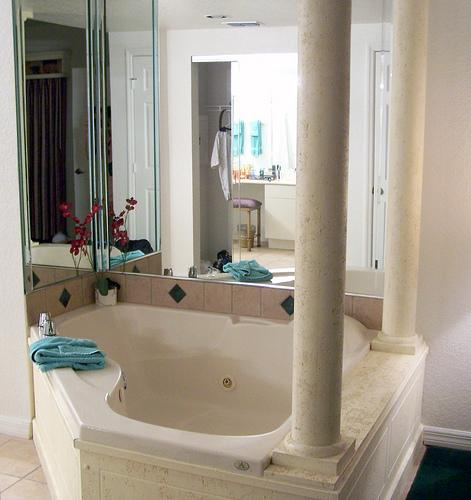What is the purpose of the round objects in the tub?

Choices:
A) drainage
B) massage
C) mood lighting
D) soap dispensing massage 